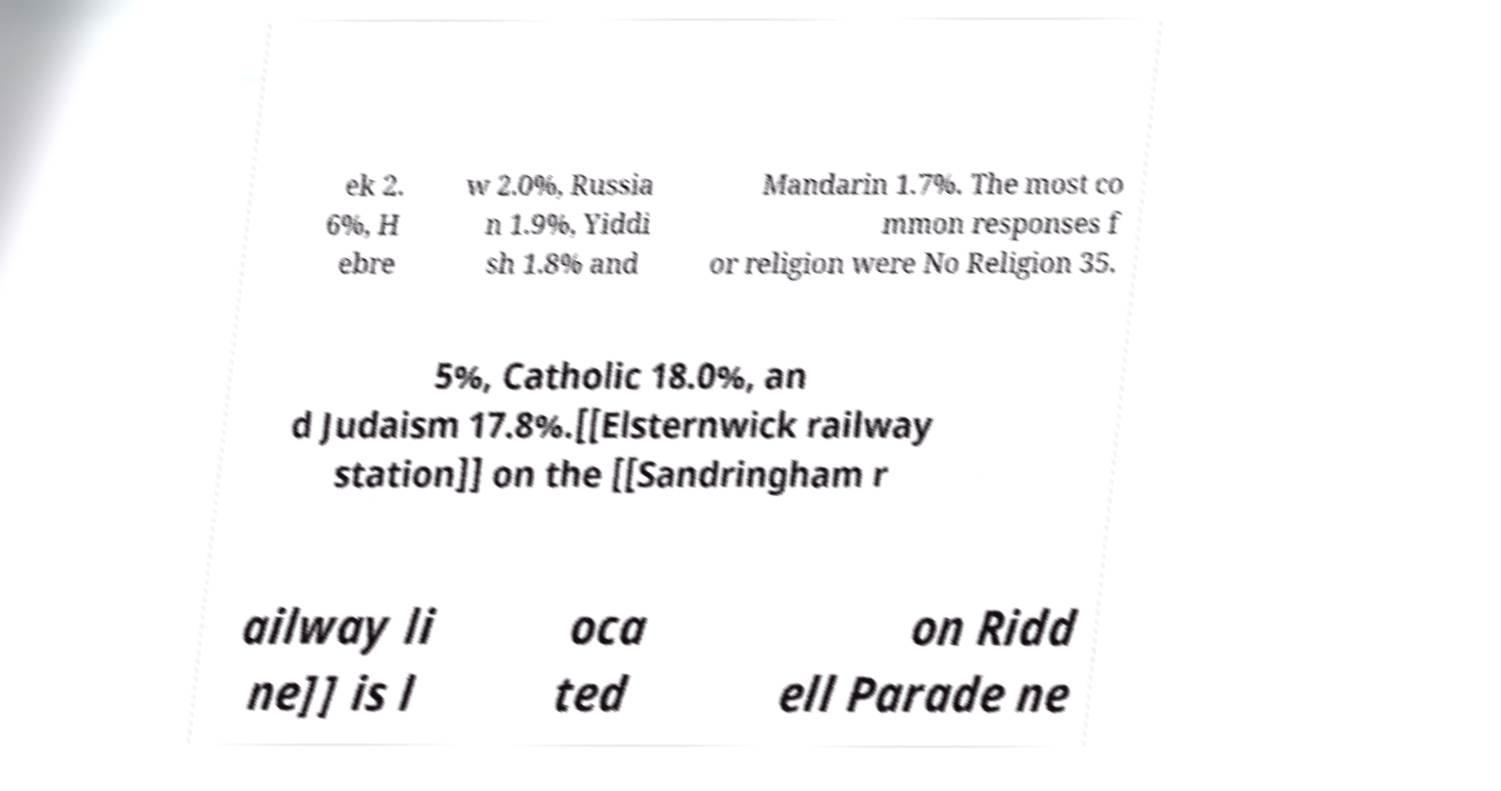Could you assist in decoding the text presented in this image and type it out clearly? ek 2. 6%, H ebre w 2.0%, Russia n 1.9%, Yiddi sh 1.8% and Mandarin 1.7%. The most co mmon responses f or religion were No Religion 35. 5%, Catholic 18.0%, an d Judaism 17.8%.[[Elsternwick railway station]] on the [[Sandringham r ailway li ne]] is l oca ted on Ridd ell Parade ne 